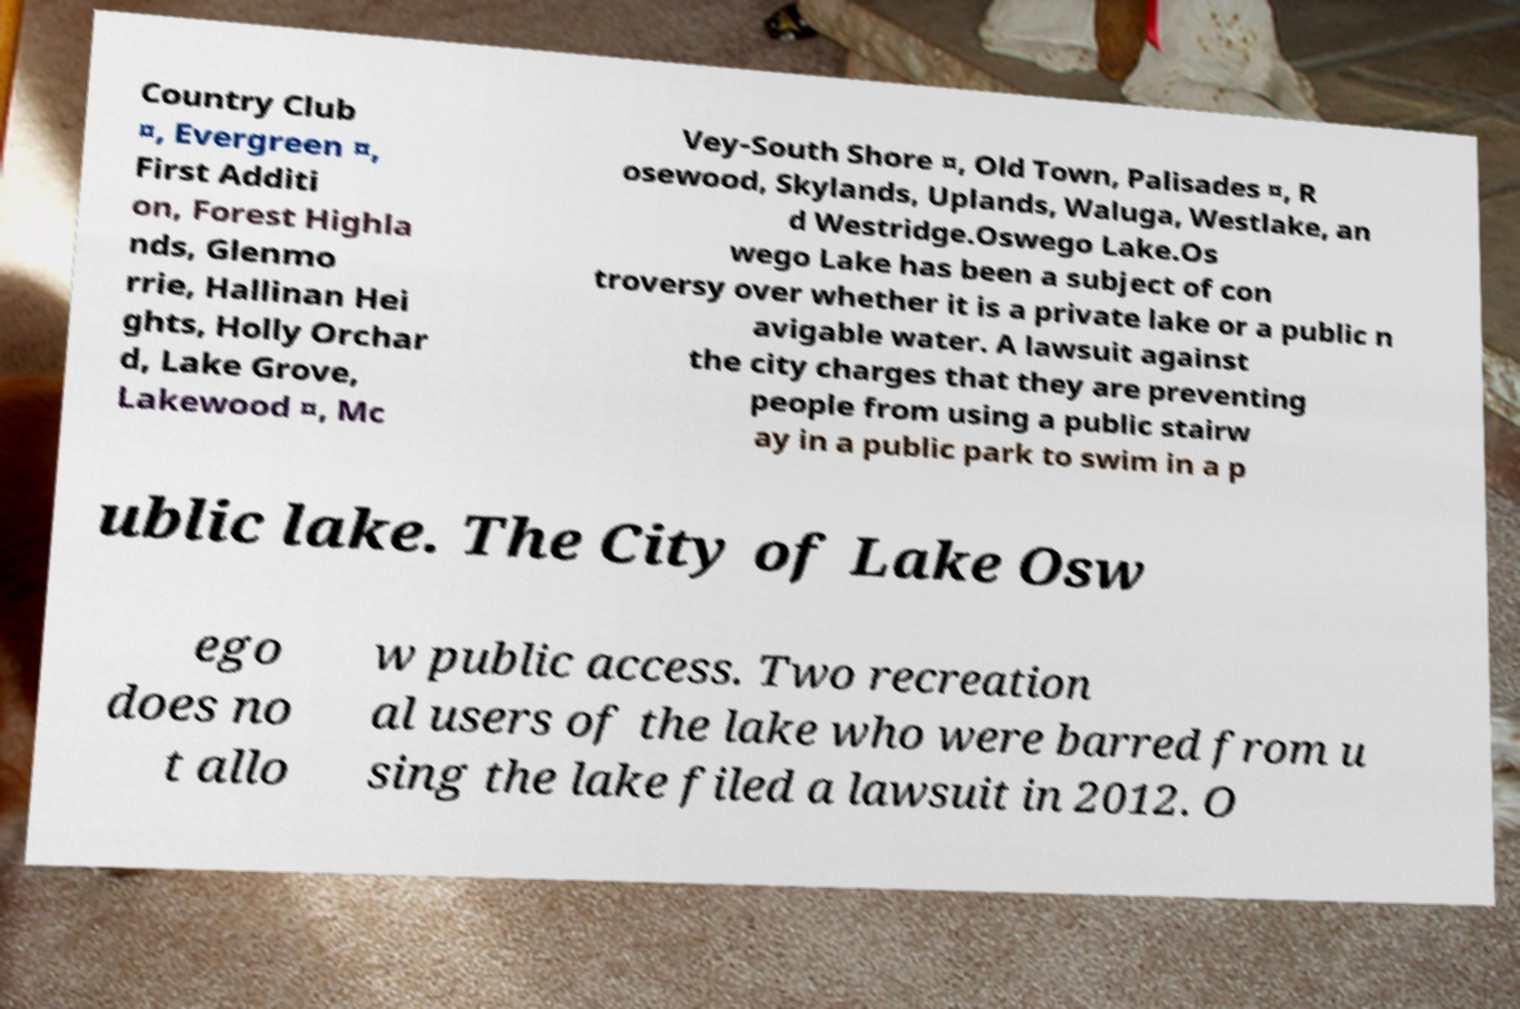Could you extract and type out the text from this image? Country Club ¤, Evergreen ¤, First Additi on, Forest Highla nds, Glenmo rrie, Hallinan Hei ghts, Holly Orchar d, Lake Grove, Lakewood ¤, Mc Vey-South Shore ¤, Old Town, Palisades ¤, R osewood, Skylands, Uplands, Waluga, Westlake, an d Westridge.Oswego Lake.Os wego Lake has been a subject of con troversy over whether it is a private lake or a public n avigable water. A lawsuit against the city charges that they are preventing people from using a public stairw ay in a public park to swim in a p ublic lake. The City of Lake Osw ego does no t allo w public access. Two recreation al users of the lake who were barred from u sing the lake filed a lawsuit in 2012. O 